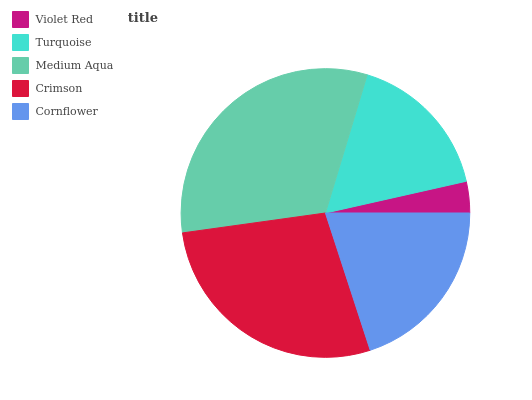Is Violet Red the minimum?
Answer yes or no. Yes. Is Medium Aqua the maximum?
Answer yes or no. Yes. Is Turquoise the minimum?
Answer yes or no. No. Is Turquoise the maximum?
Answer yes or no. No. Is Turquoise greater than Violet Red?
Answer yes or no. Yes. Is Violet Red less than Turquoise?
Answer yes or no. Yes. Is Violet Red greater than Turquoise?
Answer yes or no. No. Is Turquoise less than Violet Red?
Answer yes or no. No. Is Cornflower the high median?
Answer yes or no. Yes. Is Cornflower the low median?
Answer yes or no. Yes. Is Violet Red the high median?
Answer yes or no. No. Is Medium Aqua the low median?
Answer yes or no. No. 